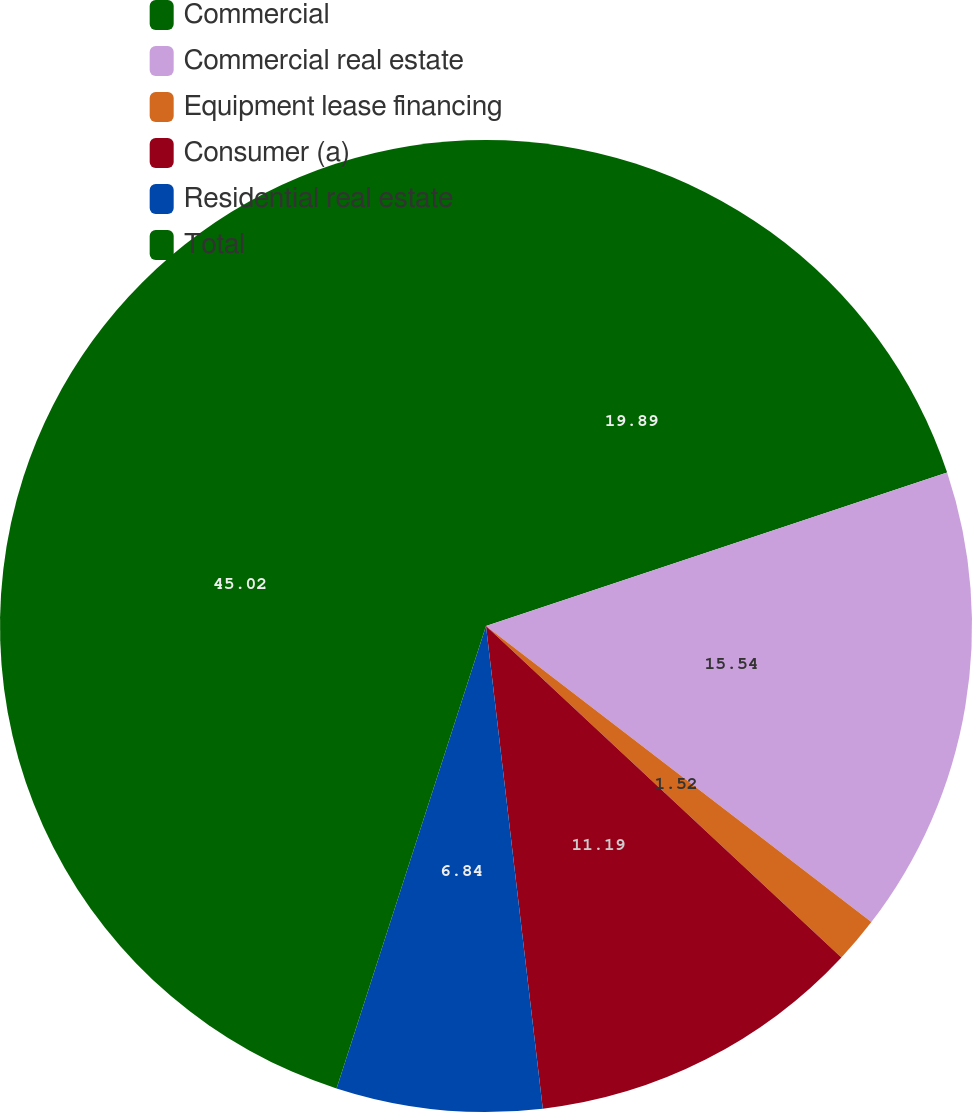Convert chart. <chart><loc_0><loc_0><loc_500><loc_500><pie_chart><fcel>Commercial<fcel>Commercial real estate<fcel>Equipment lease financing<fcel>Consumer (a)<fcel>Residential real estate<fcel>Total<nl><fcel>19.89%<fcel>15.54%<fcel>1.52%<fcel>11.19%<fcel>6.84%<fcel>45.03%<nl></chart> 